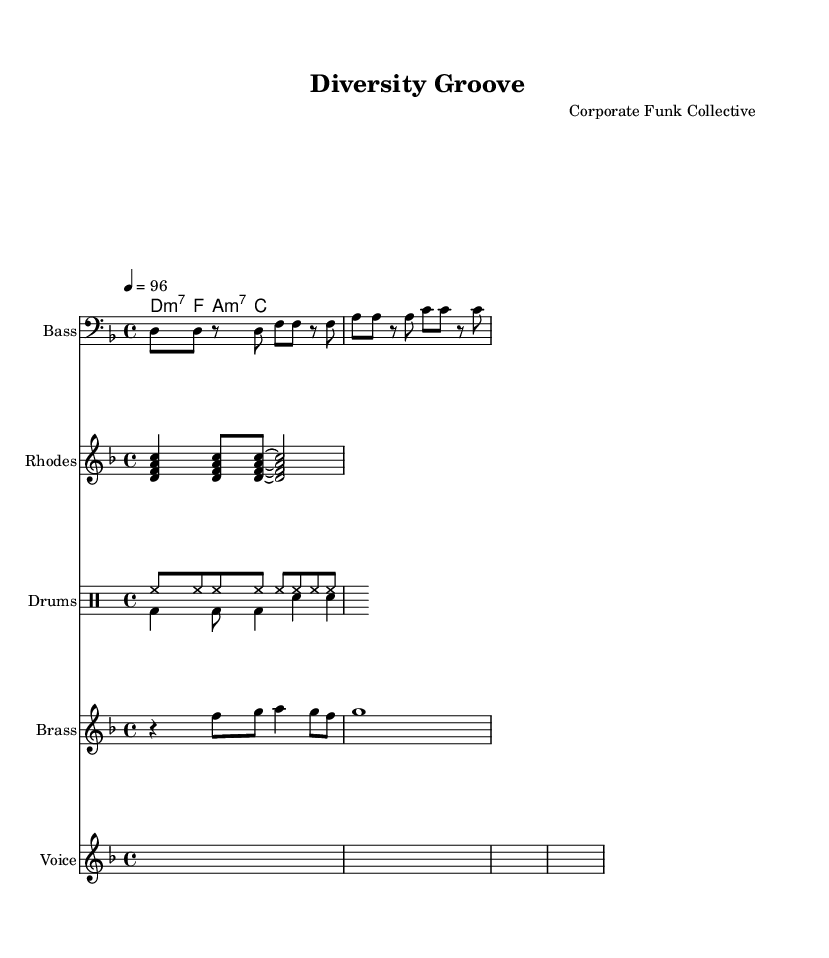What is the key signature of this music? The key signature indicated in the global section shows a D minor key, which has one flat (B flat).
Answer: D minor What is the time signature of this music? The time signature in the global section is 4/4, which means there are four beats per measure.
Answer: 4/4 What is the tempo marked on the sheet music? The tempo marking indicates a speed of 96 beats per minute (BPM), which is set by the number in the tempo section.
Answer: 96 What is the primary rhythm pattern used in the drums? The rhythmic pattern is composed of high hats and bass drums, characterized by consistent eighth notes followed by variations with snare hits, indicating a common funk groove.
Answer: Funk groove How many musical sections are present in the lyrics? The lyrics are divided clearly into two sections: the verse and the chorus, each having distinct lyrical content.
Answer: Two Which chord follows the D minor 7 chord in the progression? Referring to the chord progression in the chord mode section, the chord after D minor 7 is F major.
Answer: F What is the focus of the lyrics in this piece? The lyrics emphasize themes of workplace diversity and inclusion, highlighting the importance of different backgrounds working together.
Answer: Diversity and inclusion 